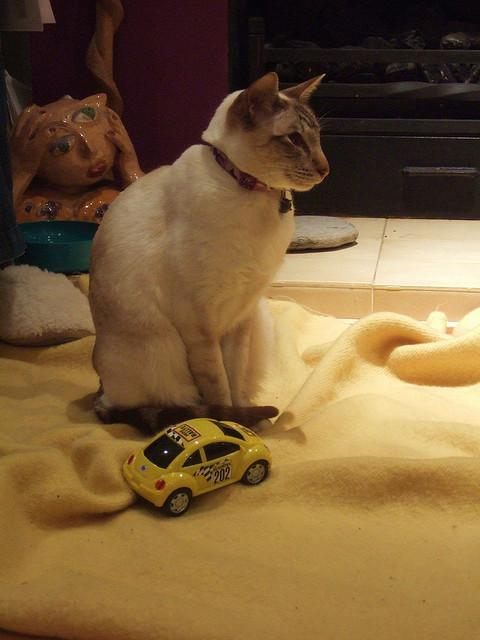What room is it?

Choices:
A) bedroom
B) kitchen
C) dining room
D) family room family room 